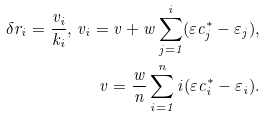Convert formula to latex. <formula><loc_0><loc_0><loc_500><loc_500>\delta r _ { i } = \frac { v _ { i } } { k _ { i } } , \, v _ { i } = v + w \sum _ { j = 1 } ^ { i } ( \varepsilon c ^ { * } _ { j } - \varepsilon _ { j } ) , \\ v = \frac { w } { n } \sum _ { i = 1 } ^ { n } i ( \varepsilon c ^ { * } _ { i } - \varepsilon _ { i } ) .</formula> 